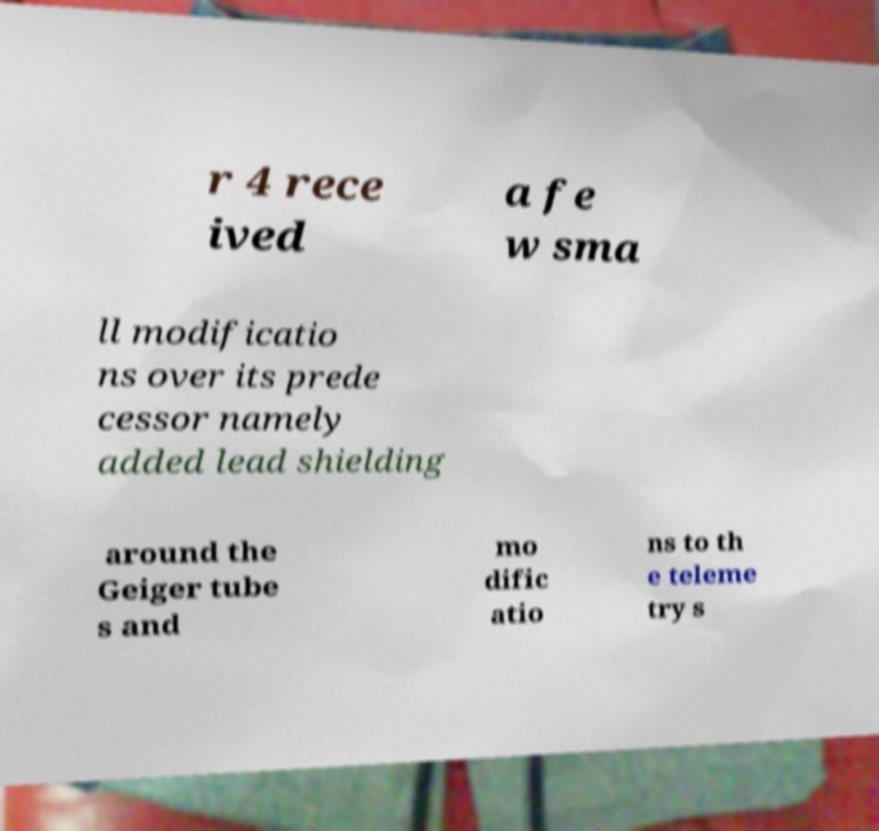What messages or text are displayed in this image? I need them in a readable, typed format. r 4 rece ived a fe w sma ll modificatio ns over its prede cessor namely added lead shielding around the Geiger tube s and mo dific atio ns to th e teleme try s 